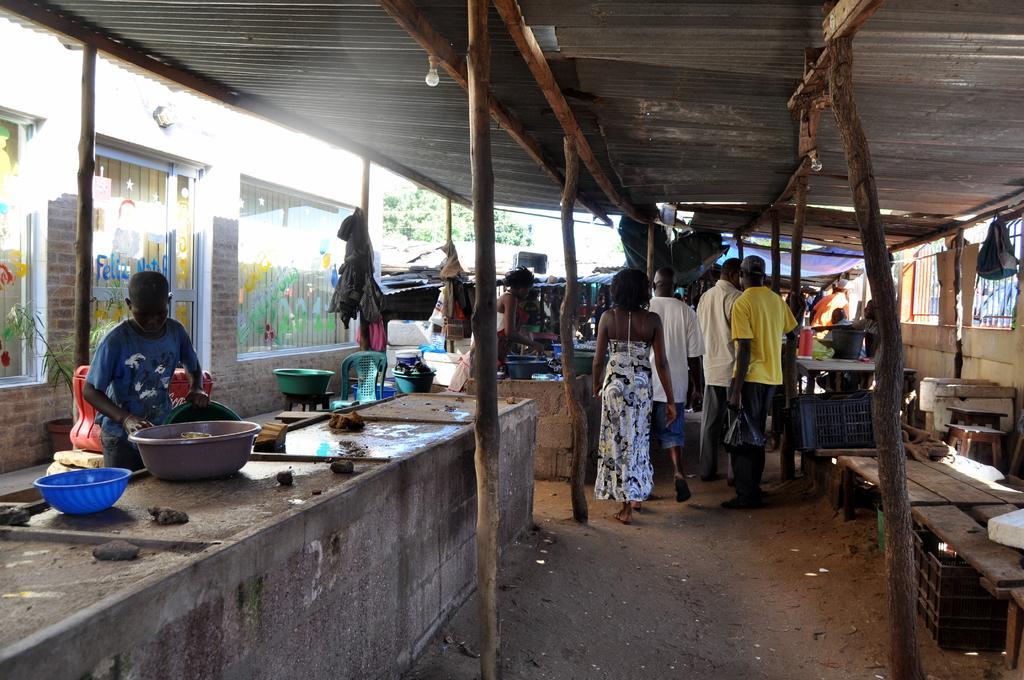Can you describe this image briefly? In this picture I can observe a person standing on the left side in front of a cement desk. There are some people standing in the middle of the picture. I can observe some wooden poles. In the background there are trees. 